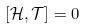<formula> <loc_0><loc_0><loc_500><loc_500>\left [ \mathcal { H } , \mathcal { T } \right ] = 0</formula> 